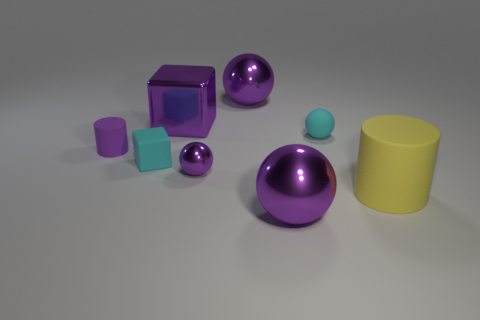There is a cyan matte cube; is its size the same as the cylinder in front of the purple matte thing?
Offer a terse response. No. Is the number of large balls that are to the right of the purple cylinder greater than the number of large yellow cylinders?
Keep it short and to the point. Yes. There is a yellow cylinder that is the same material as the cyan block; what size is it?
Offer a very short reply. Large. Is there a metal cube that has the same color as the small rubber ball?
Your answer should be very brief. No. What number of things are either tiny red rubber objects or balls right of the tiny shiny object?
Your answer should be very brief. 3. Are there more yellow objects than big metal balls?
Your response must be concise. No. The block that is the same color as the tiny cylinder is what size?
Keep it short and to the point. Large. Is there a purple block made of the same material as the small cyan ball?
Ensure brevity in your answer.  No. There is a big object that is on the left side of the tiny matte sphere and in front of the small cyan rubber sphere; what shape is it?
Provide a short and direct response. Sphere. How many other things are the same shape as the yellow object?
Your answer should be very brief. 1. 